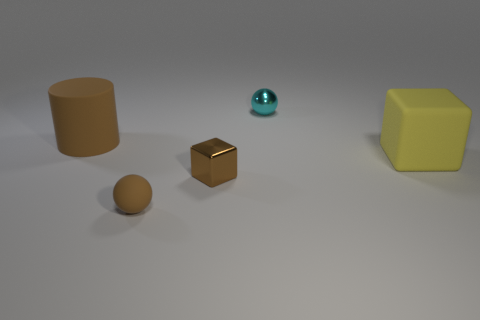Subtract all spheres. How many objects are left? 3 Add 5 large rubber blocks. How many objects exist? 10 Add 1 large yellow things. How many large yellow things exist? 2 Subtract 1 brown blocks. How many objects are left? 4 Subtract all big cylinders. Subtract all large yellow objects. How many objects are left? 3 Add 2 small matte things. How many small matte things are left? 3 